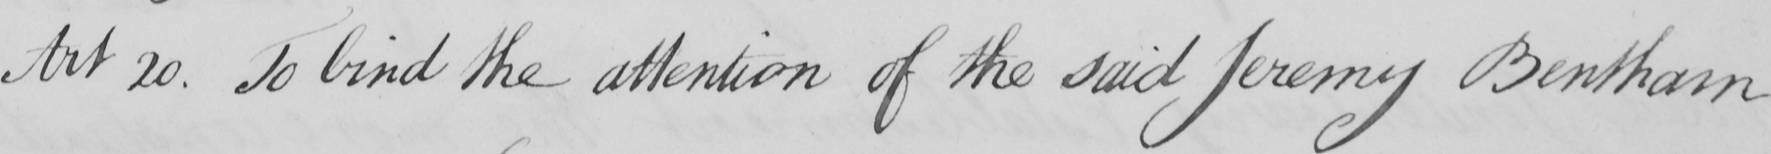What does this handwritten line say? Art 20 . To bind the attention of the said Jeremy Bentham 